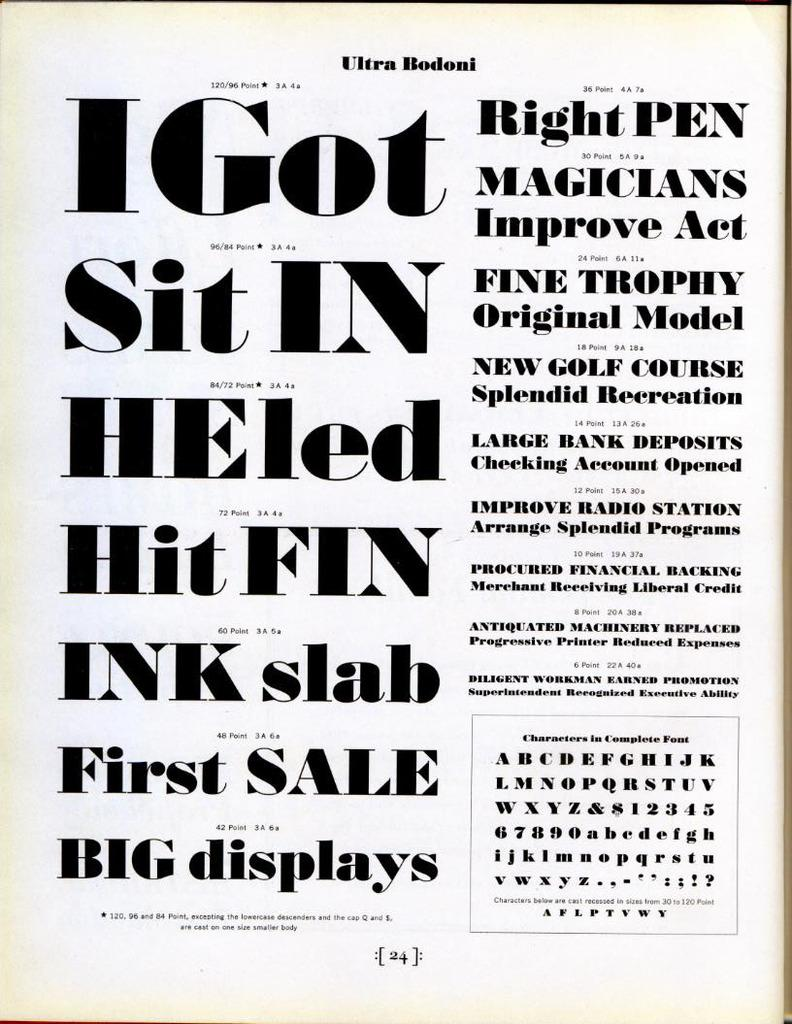<image>
Offer a succinct explanation of the picture presented. An old poster from Ultra Bodoni with various font. 